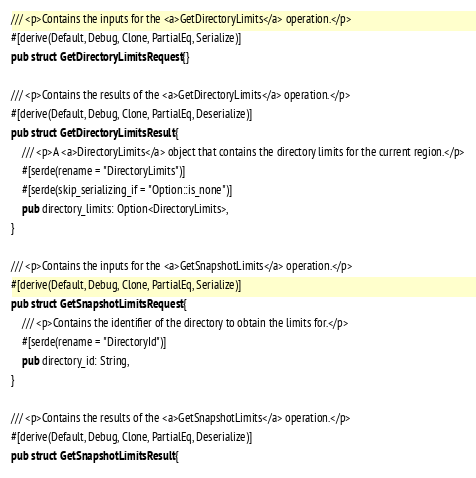Convert code to text. <code><loc_0><loc_0><loc_500><loc_500><_Rust_>
/// <p>Contains the inputs for the <a>GetDirectoryLimits</a> operation.</p>
#[derive(Default, Debug, Clone, PartialEq, Serialize)]
pub struct GetDirectoryLimitsRequest {}

/// <p>Contains the results of the <a>GetDirectoryLimits</a> operation.</p>
#[derive(Default, Debug, Clone, PartialEq, Deserialize)]
pub struct GetDirectoryLimitsResult {
    /// <p>A <a>DirectoryLimits</a> object that contains the directory limits for the current region.</p>
    #[serde(rename = "DirectoryLimits")]
    #[serde(skip_serializing_if = "Option::is_none")]
    pub directory_limits: Option<DirectoryLimits>,
}

/// <p>Contains the inputs for the <a>GetSnapshotLimits</a> operation.</p>
#[derive(Default, Debug, Clone, PartialEq, Serialize)]
pub struct GetSnapshotLimitsRequest {
    /// <p>Contains the identifier of the directory to obtain the limits for.</p>
    #[serde(rename = "DirectoryId")]
    pub directory_id: String,
}

/// <p>Contains the results of the <a>GetSnapshotLimits</a> operation.</p>
#[derive(Default, Debug, Clone, PartialEq, Deserialize)]
pub struct GetSnapshotLimitsResult {</code> 